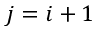<formula> <loc_0><loc_0><loc_500><loc_500>j = i + 1</formula> 